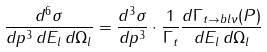<formula> <loc_0><loc_0><loc_500><loc_500>\frac { d ^ { 6 } \sigma } { d p ^ { 3 } \, d E _ { l } \, d \Omega _ { l } } = \frac { d ^ { 3 } \sigma } { d p ^ { 3 } } \cdot \frac { 1 } { \Gamma _ { t } } \frac { d \Gamma _ { t \to b l \nu } ( { P } ) } { d E _ { l } \, d \Omega _ { l } }</formula> 